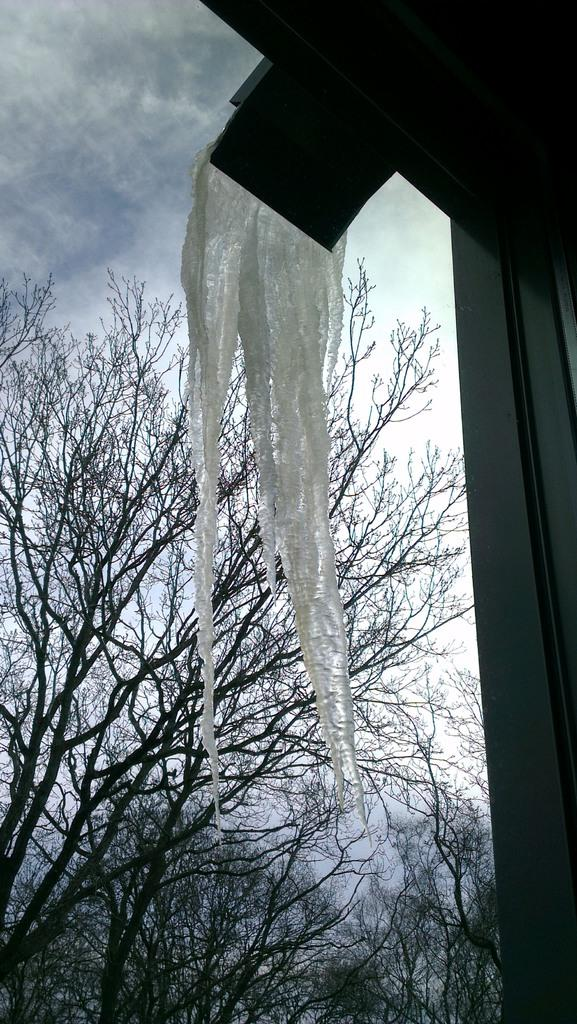What is hanging from the roof in the image? There is cloth hanging from the roof in the image. What can be seen in the background of the image? There are many trees visible in the image. Can you tell me how many beasts are walking through the trees in the image? There are no beasts visible in the image, and therefore no such activity can be observed. 